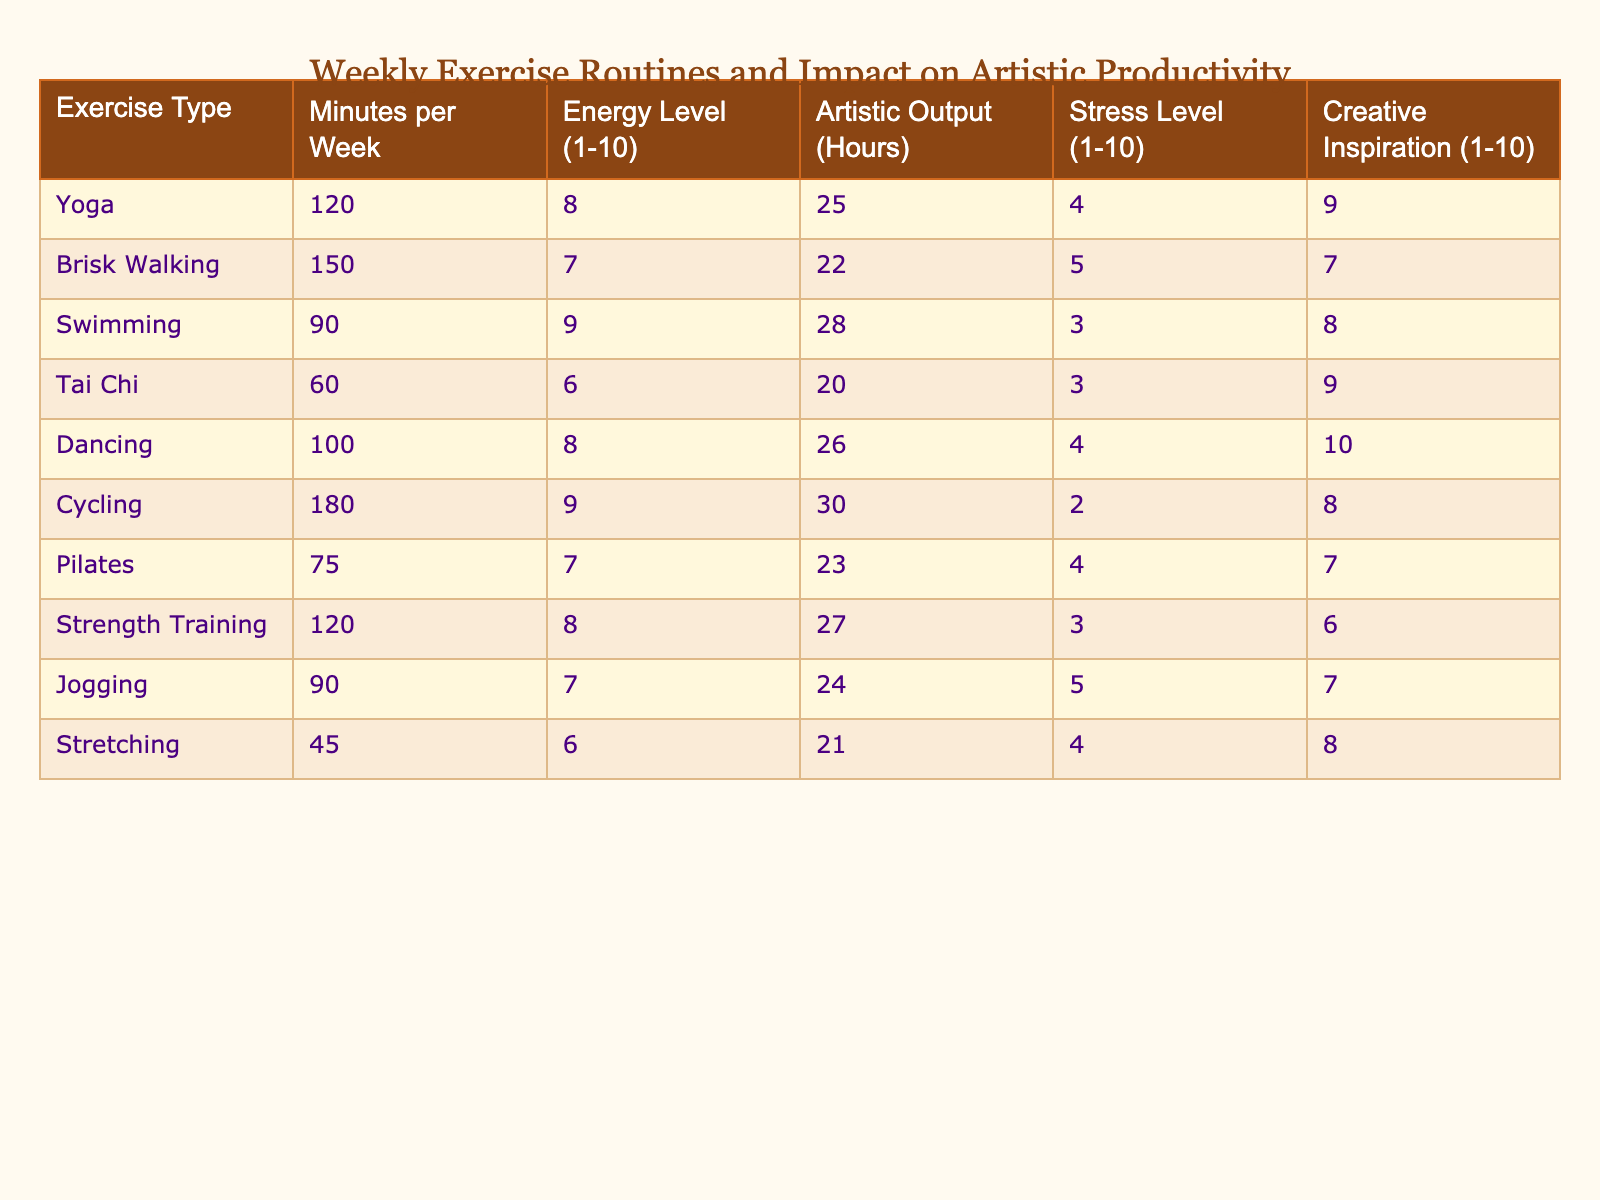What is the total amount of exercise time per week for Swimming? The table shows that Swimming has 90 minutes of exercise time per week.
Answer: 90 minutes Which exercise type has the highest energy level and what is that level? According to the table, Cycling has the highest energy level at 9.
Answer: 9 What is the artistic output in hours for Dancing? The table indicates that the artistic output for Dancing is 26 hours.
Answer: 26 hours Is the stress level for Tai Chi higher than that for Pilates? The table shows Tai Chi has a stress level of 3, while Pilates has a stress level of 4. So, the stress level for Tai Chi is not higher than that for Pilates.
Answer: No Calculate the average energy level of all exercise types listed. Adding the energy levels gives (8 + 7 + 9 + 6 + 8 + 9 + 7 + 8 + 7 + 6) = 79, and there are 10 exercises, so the average is 79/10 = 7.9.
Answer: 7.9 Which exercise type has the lowest artistic output? The table shows that Tai Chi has the lowest artistic output at 20 hours.
Answer: Tai Chi What is the difference in artistic output between Cycling and Swimming? Cycling has an output of 30 hours and Swimming has 28 hours. The difference is 30 - 28 = 2 hours.
Answer: 2 hours Which exercise type correlates with the highest creative inspiration? The table indicates that Dancing has the highest creative inspiration level of 10.
Answer: Dancing How does the stress level for Jogging compare to that of Stretching? The stress level for Jogging is 5 and for Stretching it is 4. This means Jogging has a higher stress level compared to Stretching.
Answer: Yes, Jogging is higher Find the total energy levels for all exercises combined. Summing the energy levels: (8 + 7 + 9 + 6 + 8 + 9 + 7 + 8 + 7 + 6) = 79.
Answer: 79 